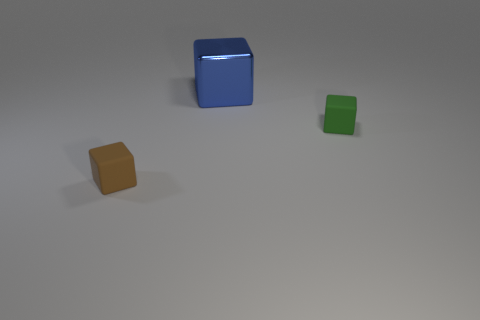Do the small brown object and the green thing have the same shape?
Keep it short and to the point. Yes. What number of brown matte things are in front of the tiny green rubber block?
Give a very brief answer. 1. What is the shape of the object that is on the right side of the big blue block that is on the left side of the tiny green cube?
Provide a short and direct response. Cube. The tiny green object that is the same material as the tiny brown cube is what shape?
Make the answer very short. Cube. Is the size of the cube to the left of the blue shiny block the same as the rubber object behind the tiny brown block?
Ensure brevity in your answer.  Yes. The small thing in front of the green matte cube has what shape?
Provide a short and direct response. Cube. What color is the large metal block?
Provide a succinct answer. Blue. There is a green matte block; is its size the same as the thing behind the green matte thing?
Give a very brief answer. No. How many metal objects are either small green blocks or small brown blocks?
Make the answer very short. 0. Is there anything else that is made of the same material as the large blue thing?
Make the answer very short. No. 